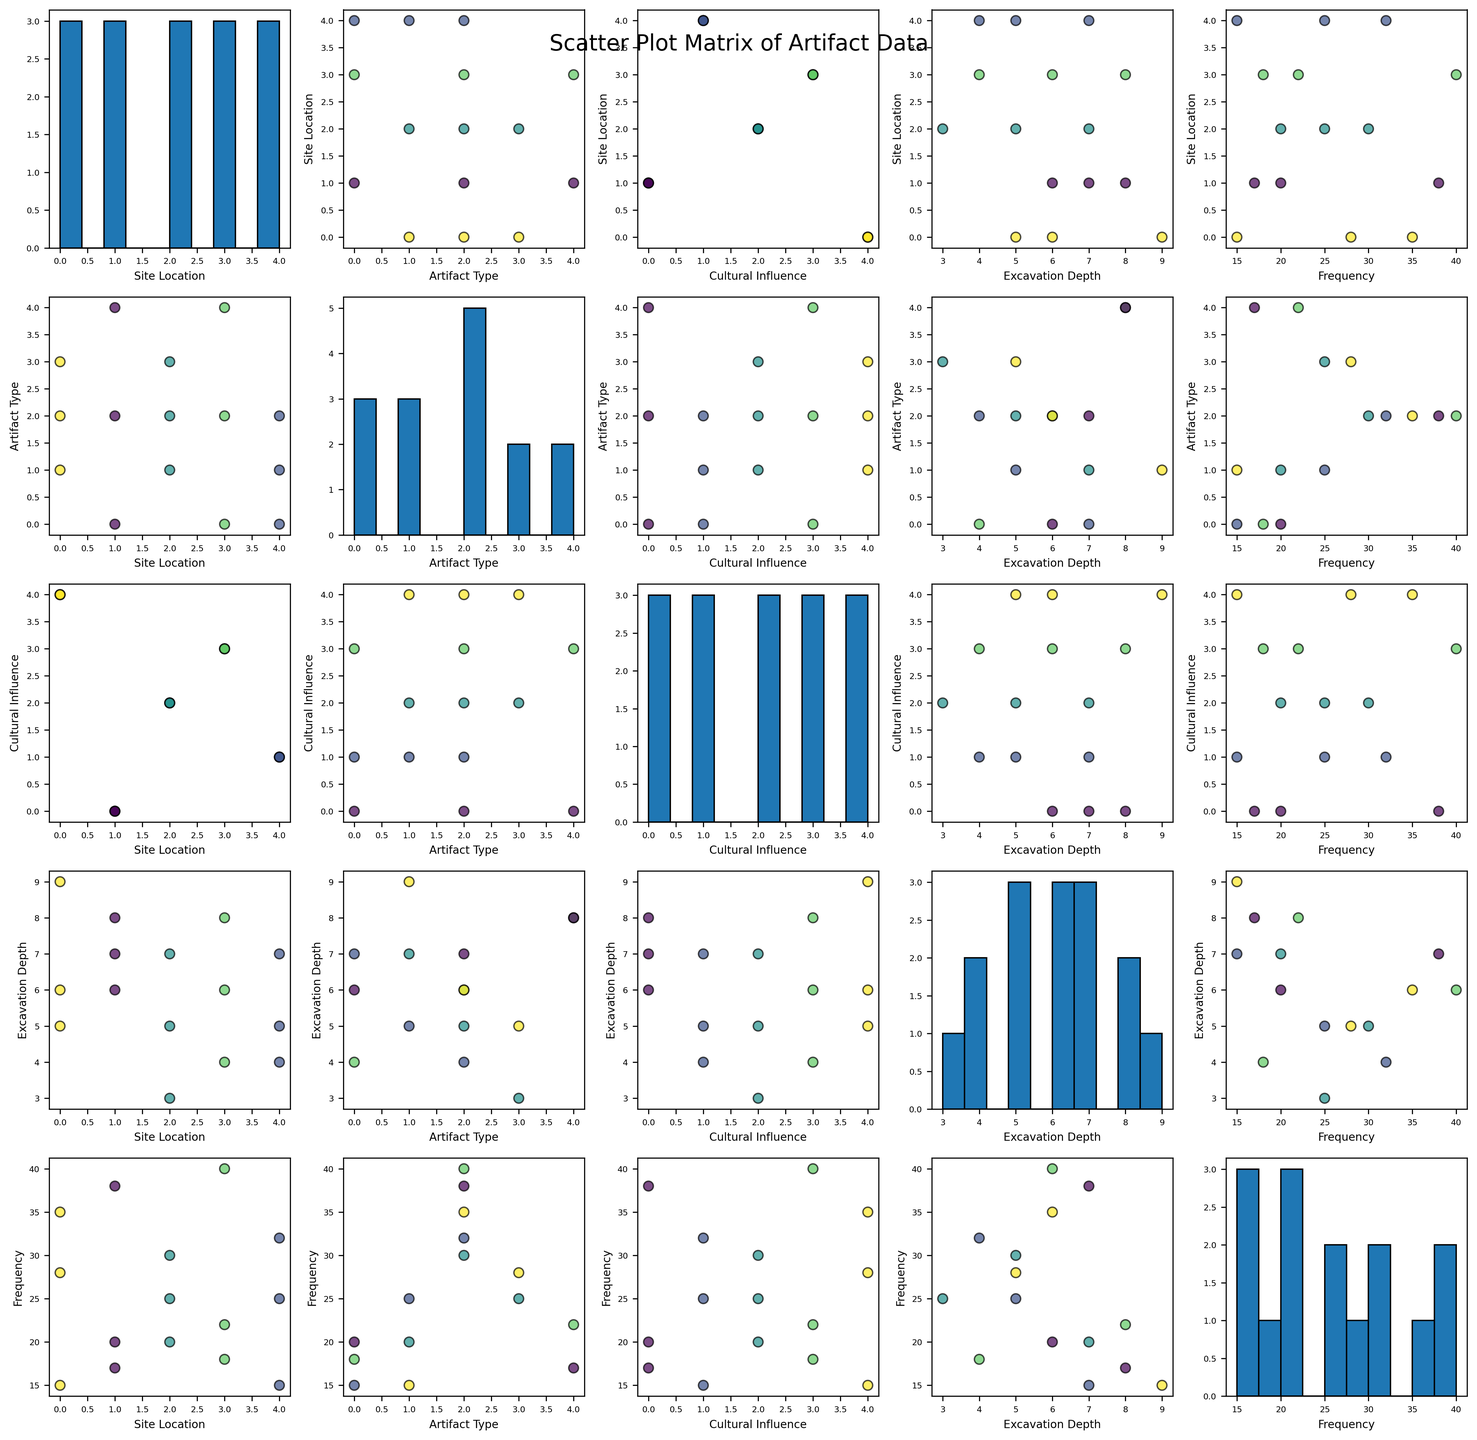what is the title of the figure? The title can be seen on top and usually describes the overall content of the figure.
Answer: Scatter Plot Matrix of Artifact Data How many variables are plotted in the scatter plot matrix? Each variable represents a different aspect and is named on the axes. Count the unique variable names.
Answer: Five What color indicates the 'Kushan Empire' in the plots? Colors represent different cultural influences and align with the key. Seek the specific color used for 'Kushan Empire'.
Answer: Determined by the colormap, typically seen as one of the distinctive colors e.g., green How are the cultural influences visually represented in the scatter plots? Cultural influences are mapped to colors that visually group data points within the scatter plots.
Answer: Colors Which site location has the highest frequency of ‘Pottery’? Identify the 'Pottery' artifact type in the related scatter plot and find the data point with the highest frequency. Then map it back to the corresponding site location.
Answer: Samarkand Is there any observable relationship between excavation depth and frequency for 'Metal Tools'? Look at plots comparing 'Excavation Depth' and 'Frequency', and focus on the points categorized as 'Metal Tools'. Check if there's a trend.
Answer: Visual trends or patterns, such as a correlation line Which artifact type has the greatest variation in frequency across all sites? Examine histogram plots where 'Artifact Type' is on the axis and compare the range/spread of frequencies for each type.
Answer: Pottery Are frequencies more concentrated around lower or higher values for 'Jewelry' across all cultural influences? Analyze the distribution of frequencies for 'Jewelry' in the relevant histogram to see where the data points cluster.
Answer: Lower values Which cultural influence contains a greater frequency of artifacts within deeper excavation depths overall? Compare scatter plots with 'Cultural Influence' and 'Excavation Depth'. Look for trends in depth for data points associated with higher frequencies.
Answer: Needs visual aggregation by color Is there any difference in the distribution of excavation depth for 'Textiles' between ‘Merv’ and ‘Bukhara’? Compare the scatter plots of excavation depths for 'Textiles' data points between these two locations to detect any shifts or differences.
Answer: Visual differences in depth patterns 